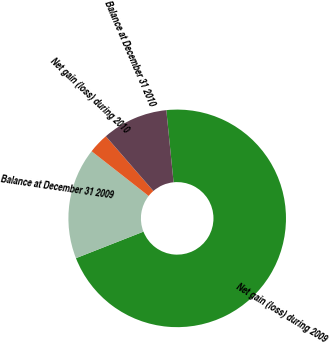Convert chart. <chart><loc_0><loc_0><loc_500><loc_500><pie_chart><fcel>Net gain (loss) during 2009<fcel>Balance at December 31 2009<fcel>Net gain (loss) during 2010<fcel>Balance at December 31 2010<nl><fcel>70.64%<fcel>16.55%<fcel>3.03%<fcel>9.79%<nl></chart> 